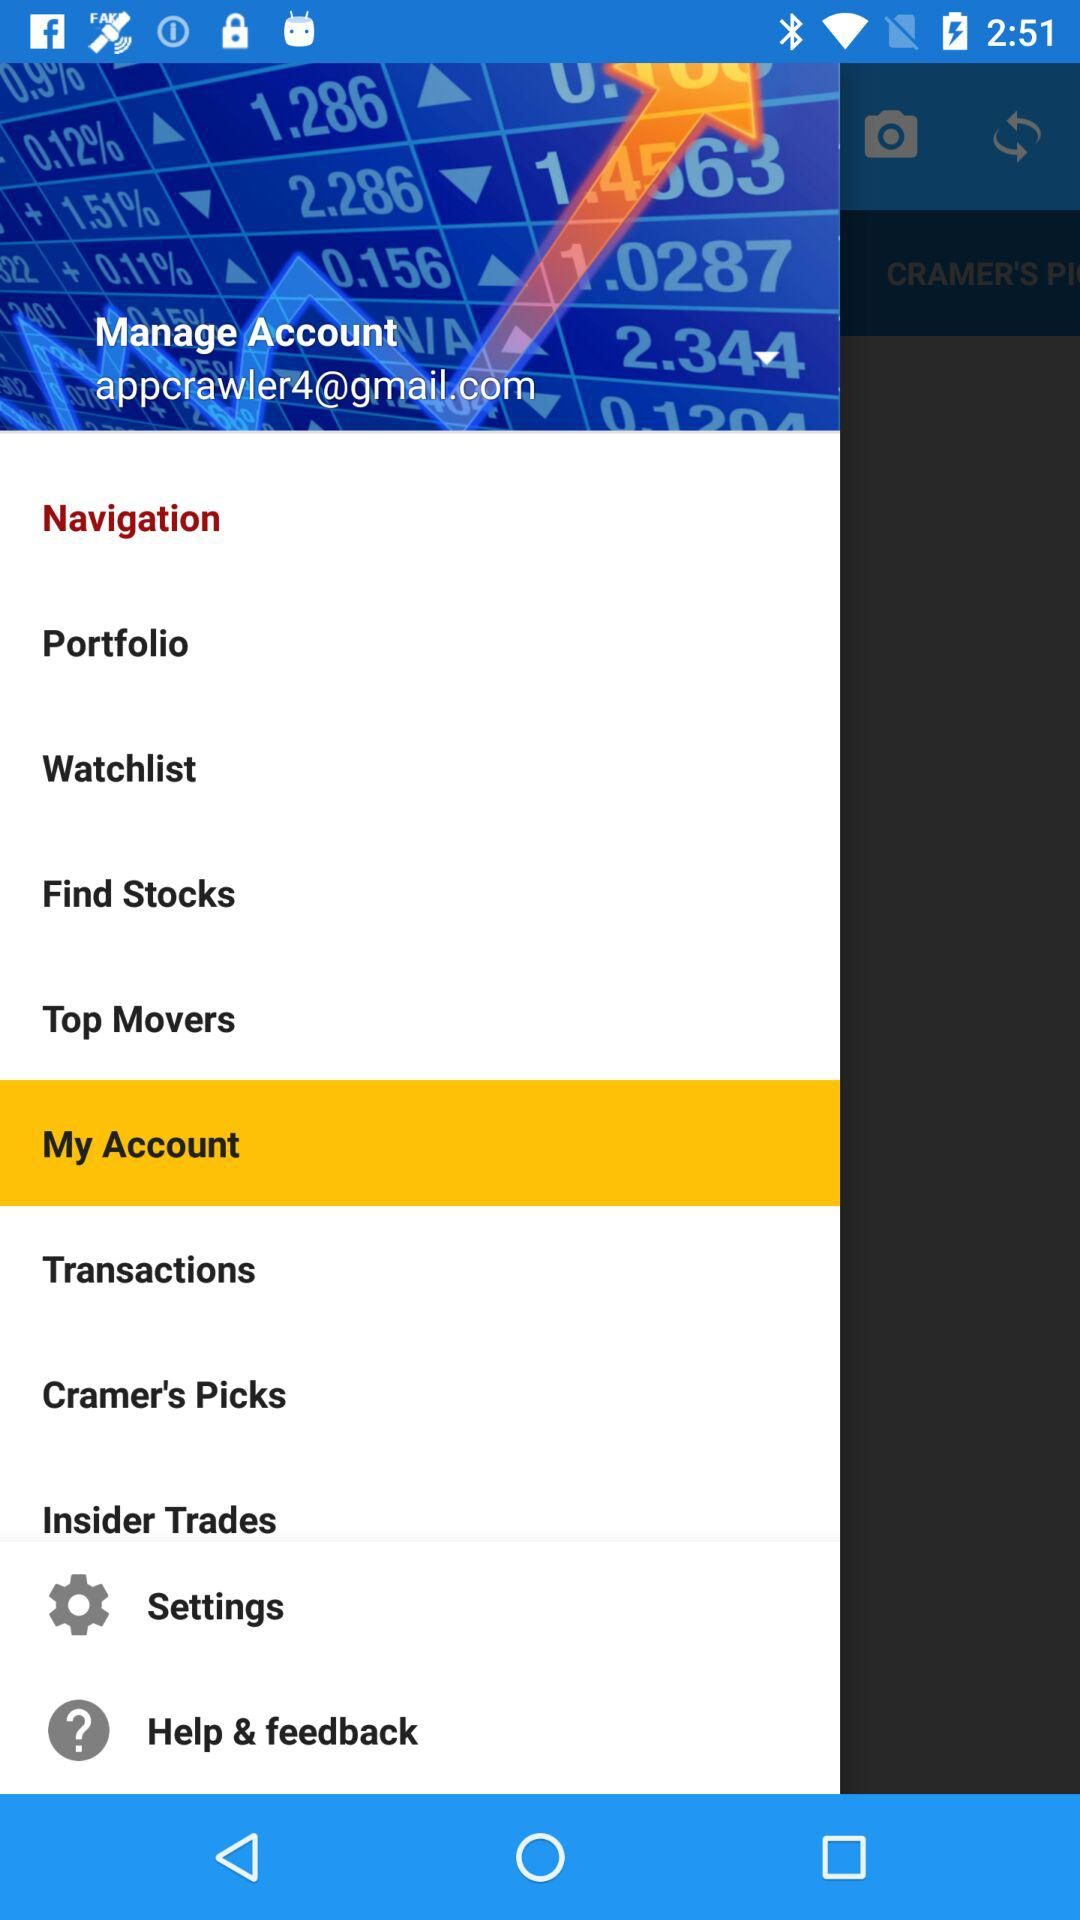Which option is selected?
Answer the question using a single word or phrase. The selected option is "My Account" 